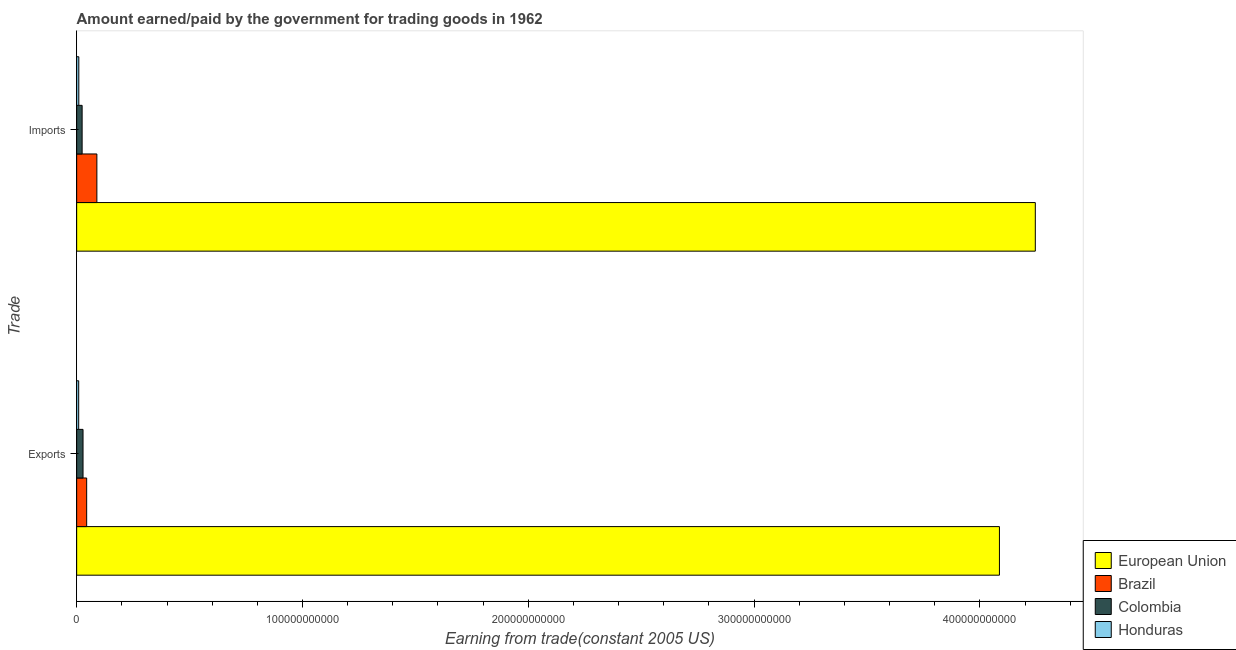How many different coloured bars are there?
Your response must be concise. 4. Are the number of bars on each tick of the Y-axis equal?
Offer a very short reply. Yes. How many bars are there on the 2nd tick from the bottom?
Offer a terse response. 4. What is the label of the 2nd group of bars from the top?
Give a very brief answer. Exports. What is the amount paid for imports in Honduras?
Your answer should be compact. 9.55e+08. Across all countries, what is the maximum amount earned from exports?
Keep it short and to the point. 4.09e+11. Across all countries, what is the minimum amount paid for imports?
Offer a terse response. 9.55e+08. In which country was the amount paid for imports minimum?
Offer a terse response. Honduras. What is the total amount earned from exports in the graph?
Offer a terse response. 4.17e+11. What is the difference between the amount paid for imports in Colombia and that in Brazil?
Ensure brevity in your answer.  -6.53e+09. What is the difference between the amount earned from exports in Honduras and the amount paid for imports in European Union?
Your answer should be very brief. -4.24e+11. What is the average amount paid for imports per country?
Your answer should be compact. 1.09e+11. What is the difference between the amount earned from exports and amount paid for imports in European Union?
Provide a short and direct response. -1.59e+1. In how many countries, is the amount paid for imports greater than 160000000000 US$?
Offer a terse response. 1. What is the ratio of the amount paid for imports in European Union to that in Honduras?
Offer a terse response. 444.71. What does the 4th bar from the bottom in Imports represents?
Offer a very short reply. Honduras. How many bars are there?
Your response must be concise. 8. Are all the bars in the graph horizontal?
Your answer should be compact. Yes. How many countries are there in the graph?
Keep it short and to the point. 4. What is the difference between two consecutive major ticks on the X-axis?
Provide a short and direct response. 1.00e+11. Are the values on the major ticks of X-axis written in scientific E-notation?
Provide a succinct answer. No. How are the legend labels stacked?
Give a very brief answer. Vertical. What is the title of the graph?
Give a very brief answer. Amount earned/paid by the government for trading goods in 1962. Does "European Union" appear as one of the legend labels in the graph?
Provide a short and direct response. Yes. What is the label or title of the X-axis?
Give a very brief answer. Earning from trade(constant 2005 US). What is the label or title of the Y-axis?
Keep it short and to the point. Trade. What is the Earning from trade(constant 2005 US) of European Union in Exports?
Your answer should be very brief. 4.09e+11. What is the Earning from trade(constant 2005 US) in Brazil in Exports?
Offer a very short reply. 4.43e+09. What is the Earning from trade(constant 2005 US) in Colombia in Exports?
Make the answer very short. 2.82e+09. What is the Earning from trade(constant 2005 US) in Honduras in Exports?
Your answer should be very brief. 8.95e+08. What is the Earning from trade(constant 2005 US) in European Union in Imports?
Keep it short and to the point. 4.24e+11. What is the Earning from trade(constant 2005 US) in Brazil in Imports?
Provide a succinct answer. 8.95e+09. What is the Earning from trade(constant 2005 US) in Colombia in Imports?
Offer a very short reply. 2.42e+09. What is the Earning from trade(constant 2005 US) in Honduras in Imports?
Make the answer very short. 9.55e+08. Across all Trade, what is the maximum Earning from trade(constant 2005 US) of European Union?
Provide a succinct answer. 4.24e+11. Across all Trade, what is the maximum Earning from trade(constant 2005 US) in Brazil?
Give a very brief answer. 8.95e+09. Across all Trade, what is the maximum Earning from trade(constant 2005 US) of Colombia?
Keep it short and to the point. 2.82e+09. Across all Trade, what is the maximum Earning from trade(constant 2005 US) in Honduras?
Provide a succinct answer. 9.55e+08. Across all Trade, what is the minimum Earning from trade(constant 2005 US) in European Union?
Your response must be concise. 4.09e+11. Across all Trade, what is the minimum Earning from trade(constant 2005 US) in Brazil?
Provide a succinct answer. 4.43e+09. Across all Trade, what is the minimum Earning from trade(constant 2005 US) in Colombia?
Ensure brevity in your answer.  2.42e+09. Across all Trade, what is the minimum Earning from trade(constant 2005 US) of Honduras?
Provide a succinct answer. 8.95e+08. What is the total Earning from trade(constant 2005 US) of European Union in the graph?
Make the answer very short. 8.33e+11. What is the total Earning from trade(constant 2005 US) in Brazil in the graph?
Offer a very short reply. 1.34e+1. What is the total Earning from trade(constant 2005 US) of Colombia in the graph?
Provide a short and direct response. 5.24e+09. What is the total Earning from trade(constant 2005 US) of Honduras in the graph?
Offer a terse response. 1.85e+09. What is the difference between the Earning from trade(constant 2005 US) in European Union in Exports and that in Imports?
Your response must be concise. -1.59e+1. What is the difference between the Earning from trade(constant 2005 US) of Brazil in Exports and that in Imports?
Offer a terse response. -4.52e+09. What is the difference between the Earning from trade(constant 2005 US) in Colombia in Exports and that in Imports?
Your answer should be very brief. 3.98e+08. What is the difference between the Earning from trade(constant 2005 US) of Honduras in Exports and that in Imports?
Offer a terse response. -6.00e+07. What is the difference between the Earning from trade(constant 2005 US) of European Union in Exports and the Earning from trade(constant 2005 US) of Brazil in Imports?
Keep it short and to the point. 4.00e+11. What is the difference between the Earning from trade(constant 2005 US) of European Union in Exports and the Earning from trade(constant 2005 US) of Colombia in Imports?
Offer a very short reply. 4.06e+11. What is the difference between the Earning from trade(constant 2005 US) of European Union in Exports and the Earning from trade(constant 2005 US) of Honduras in Imports?
Your response must be concise. 4.08e+11. What is the difference between the Earning from trade(constant 2005 US) of Brazil in Exports and the Earning from trade(constant 2005 US) of Colombia in Imports?
Provide a succinct answer. 2.01e+09. What is the difference between the Earning from trade(constant 2005 US) of Brazil in Exports and the Earning from trade(constant 2005 US) of Honduras in Imports?
Your answer should be compact. 3.48e+09. What is the difference between the Earning from trade(constant 2005 US) in Colombia in Exports and the Earning from trade(constant 2005 US) in Honduras in Imports?
Your answer should be compact. 1.86e+09. What is the average Earning from trade(constant 2005 US) in European Union per Trade?
Offer a very short reply. 4.17e+11. What is the average Earning from trade(constant 2005 US) in Brazil per Trade?
Provide a short and direct response. 6.69e+09. What is the average Earning from trade(constant 2005 US) in Colombia per Trade?
Your answer should be compact. 2.62e+09. What is the average Earning from trade(constant 2005 US) of Honduras per Trade?
Give a very brief answer. 9.25e+08. What is the difference between the Earning from trade(constant 2005 US) of European Union and Earning from trade(constant 2005 US) of Brazil in Exports?
Make the answer very short. 4.04e+11. What is the difference between the Earning from trade(constant 2005 US) of European Union and Earning from trade(constant 2005 US) of Colombia in Exports?
Provide a short and direct response. 4.06e+11. What is the difference between the Earning from trade(constant 2005 US) in European Union and Earning from trade(constant 2005 US) in Honduras in Exports?
Offer a terse response. 4.08e+11. What is the difference between the Earning from trade(constant 2005 US) of Brazil and Earning from trade(constant 2005 US) of Colombia in Exports?
Offer a very short reply. 1.61e+09. What is the difference between the Earning from trade(constant 2005 US) of Brazil and Earning from trade(constant 2005 US) of Honduras in Exports?
Ensure brevity in your answer.  3.54e+09. What is the difference between the Earning from trade(constant 2005 US) in Colombia and Earning from trade(constant 2005 US) in Honduras in Exports?
Provide a short and direct response. 1.92e+09. What is the difference between the Earning from trade(constant 2005 US) of European Union and Earning from trade(constant 2005 US) of Brazil in Imports?
Your response must be concise. 4.16e+11. What is the difference between the Earning from trade(constant 2005 US) in European Union and Earning from trade(constant 2005 US) in Colombia in Imports?
Provide a succinct answer. 4.22e+11. What is the difference between the Earning from trade(constant 2005 US) of European Union and Earning from trade(constant 2005 US) of Honduras in Imports?
Provide a succinct answer. 4.24e+11. What is the difference between the Earning from trade(constant 2005 US) of Brazil and Earning from trade(constant 2005 US) of Colombia in Imports?
Your answer should be very brief. 6.53e+09. What is the difference between the Earning from trade(constant 2005 US) of Brazil and Earning from trade(constant 2005 US) of Honduras in Imports?
Your answer should be compact. 7.99e+09. What is the difference between the Earning from trade(constant 2005 US) in Colombia and Earning from trade(constant 2005 US) in Honduras in Imports?
Offer a terse response. 1.47e+09. What is the ratio of the Earning from trade(constant 2005 US) in European Union in Exports to that in Imports?
Offer a terse response. 0.96. What is the ratio of the Earning from trade(constant 2005 US) in Brazil in Exports to that in Imports?
Keep it short and to the point. 0.5. What is the ratio of the Earning from trade(constant 2005 US) of Colombia in Exports to that in Imports?
Ensure brevity in your answer.  1.16. What is the ratio of the Earning from trade(constant 2005 US) of Honduras in Exports to that in Imports?
Your answer should be compact. 0.94. What is the difference between the highest and the second highest Earning from trade(constant 2005 US) in European Union?
Provide a succinct answer. 1.59e+1. What is the difference between the highest and the second highest Earning from trade(constant 2005 US) in Brazil?
Your answer should be very brief. 4.52e+09. What is the difference between the highest and the second highest Earning from trade(constant 2005 US) of Colombia?
Provide a succinct answer. 3.98e+08. What is the difference between the highest and the second highest Earning from trade(constant 2005 US) in Honduras?
Your answer should be very brief. 6.00e+07. What is the difference between the highest and the lowest Earning from trade(constant 2005 US) of European Union?
Your answer should be compact. 1.59e+1. What is the difference between the highest and the lowest Earning from trade(constant 2005 US) in Brazil?
Ensure brevity in your answer.  4.52e+09. What is the difference between the highest and the lowest Earning from trade(constant 2005 US) of Colombia?
Ensure brevity in your answer.  3.98e+08. What is the difference between the highest and the lowest Earning from trade(constant 2005 US) of Honduras?
Offer a very short reply. 6.00e+07. 